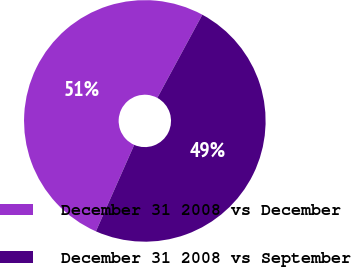Convert chart to OTSL. <chart><loc_0><loc_0><loc_500><loc_500><pie_chart><fcel>December 31 2008 vs December<fcel>December 31 2008 vs September<nl><fcel>51.26%<fcel>48.74%<nl></chart> 